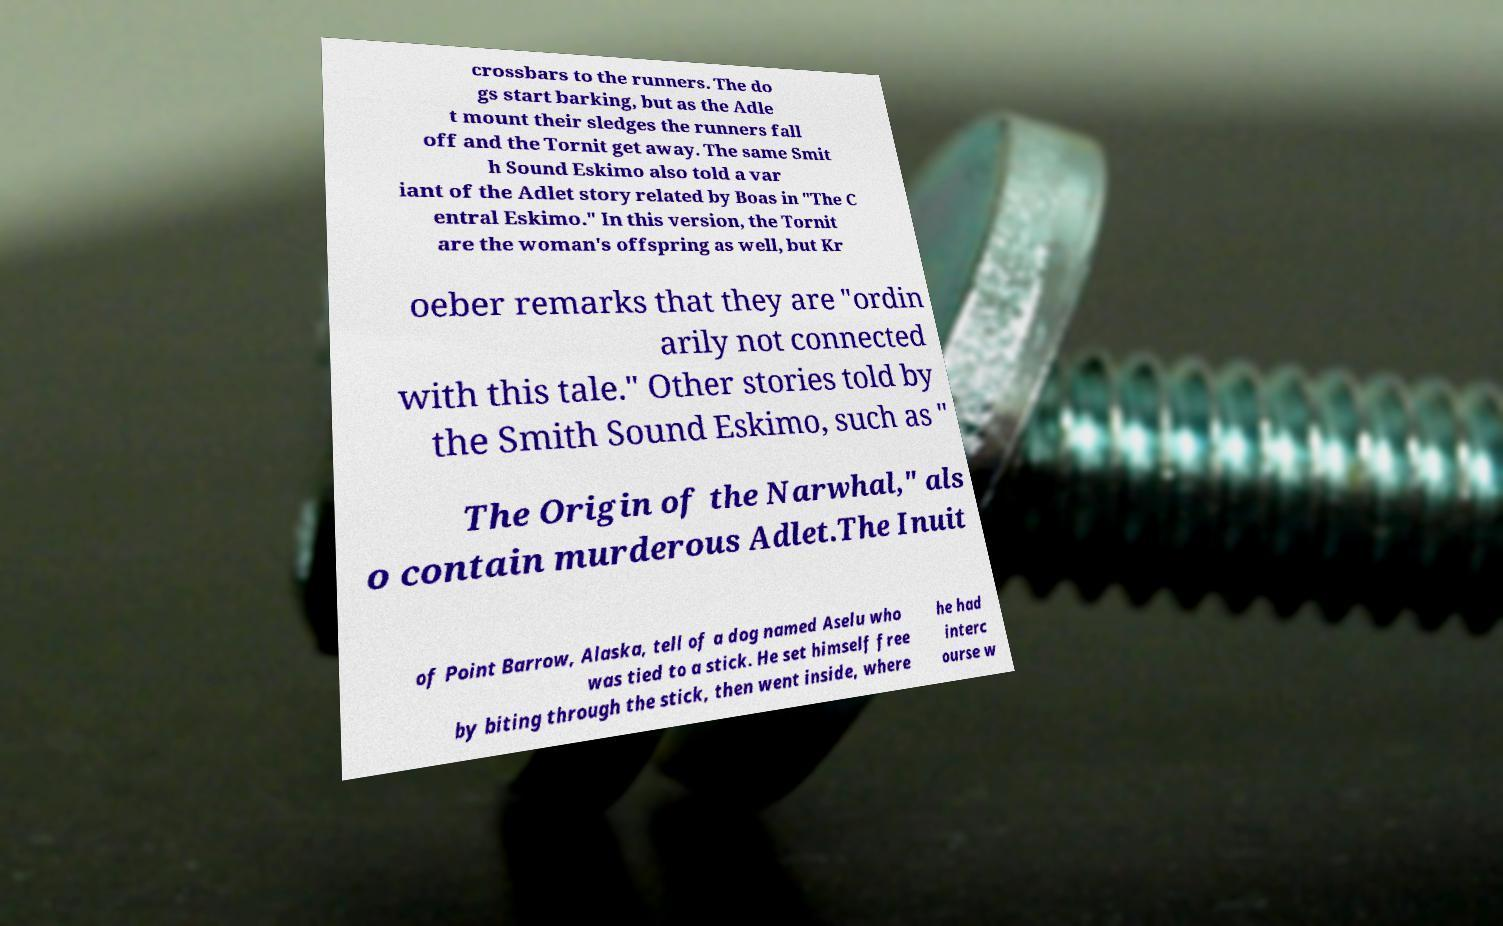There's text embedded in this image that I need extracted. Can you transcribe it verbatim? crossbars to the runners. The do gs start barking, but as the Adle t mount their sledges the runners fall off and the Tornit get away. The same Smit h Sound Eskimo also told a var iant of the Adlet story related by Boas in "The C entral Eskimo." In this version, the Tornit are the woman's offspring as well, but Kr oeber remarks that they are "ordin arily not connected with this tale." Other stories told by the Smith Sound Eskimo, such as " The Origin of the Narwhal," als o contain murderous Adlet.The Inuit of Point Barrow, Alaska, tell of a dog named Aselu who was tied to a stick. He set himself free by biting through the stick, then went inside, where he had interc ourse w 